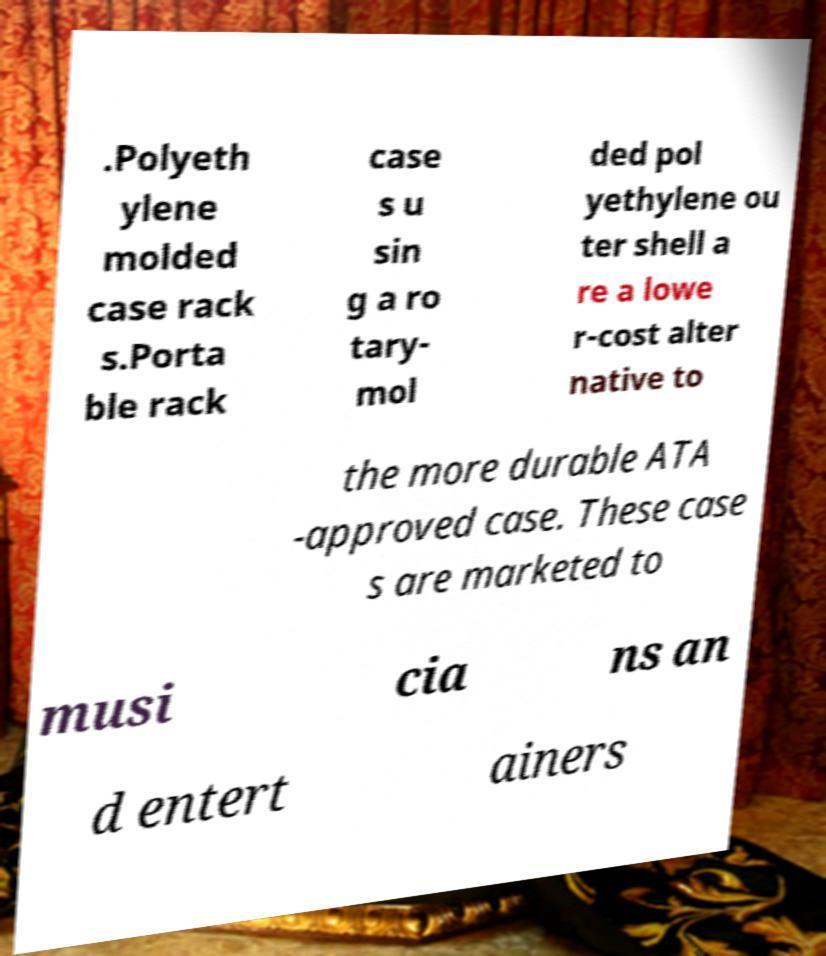Could you extract and type out the text from this image? .Polyeth ylene molded case rack s.Porta ble rack case s u sin g a ro tary- mol ded pol yethylene ou ter shell a re a lowe r-cost alter native to the more durable ATA -approved case. These case s are marketed to musi cia ns an d entert ainers 